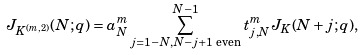Convert formula to latex. <formula><loc_0><loc_0><loc_500><loc_500>J _ { K ^ { ( m , 2 ) } } ( N ; q ) = a _ { N } ^ { m } \sum _ { j = 1 - N , N - j + 1 \text { even} } ^ { N - 1 } t _ { j , N } ^ { m } J _ { K } ( N + j ; q ) ,</formula> 